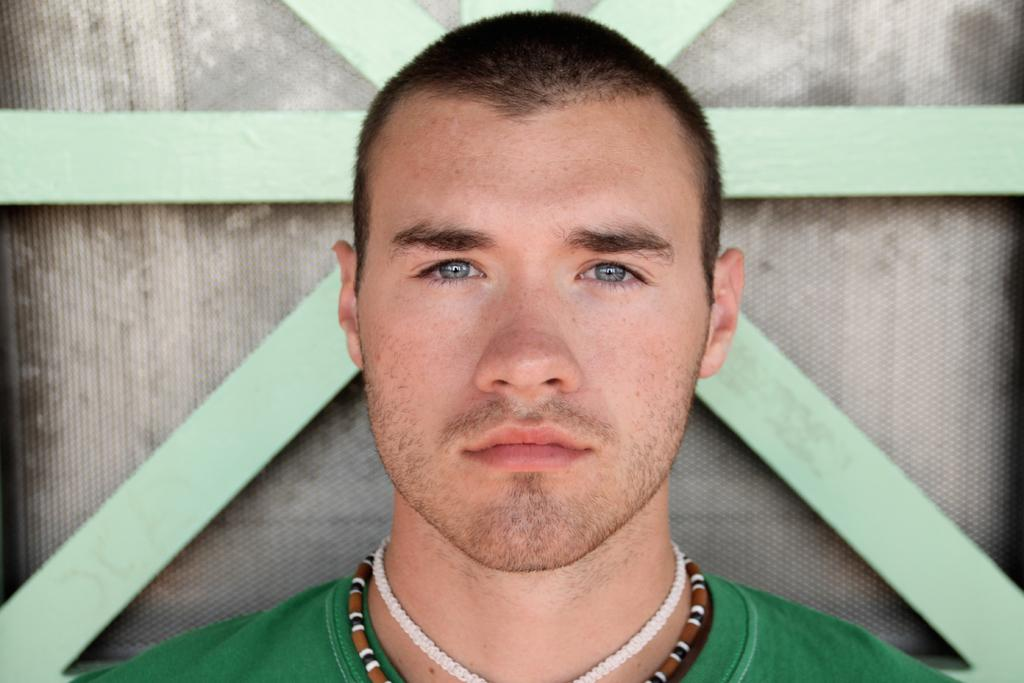What is the person in the image wearing? The person is wearing a green T-shirt. What is the person doing in the image? The person is watching something. What can be seen in the background of the image? There is a fence in the background of the image. What is located beside the fence? There is an object beside the fence. What type of steel is used to make the dime that the person is pointing at in the image? There is no dime or pointing gesture in the image; the person is simply watching something. 